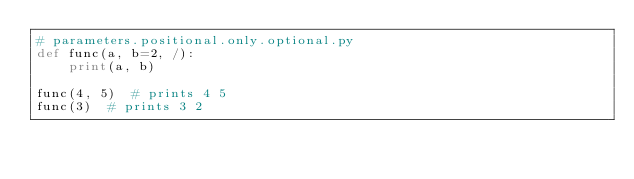Convert code to text. <code><loc_0><loc_0><loc_500><loc_500><_Python_># parameters.positional.only.optional.py
def func(a, b=2, /):
    print(a, b)

func(4, 5)  # prints 4 5
func(3)  # prints 3 2
</code> 